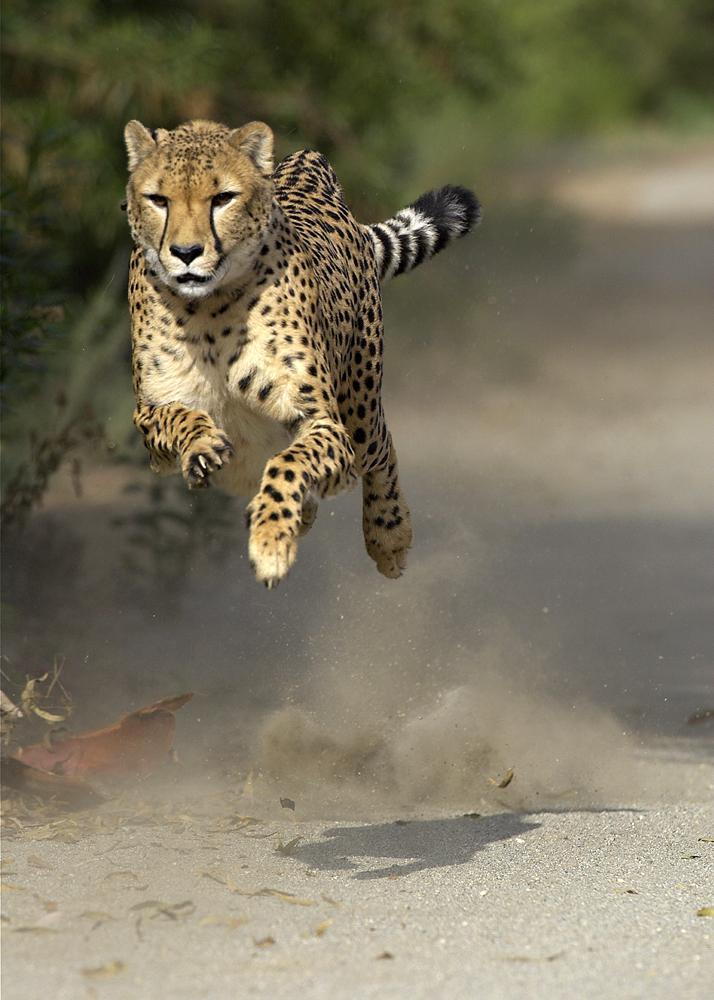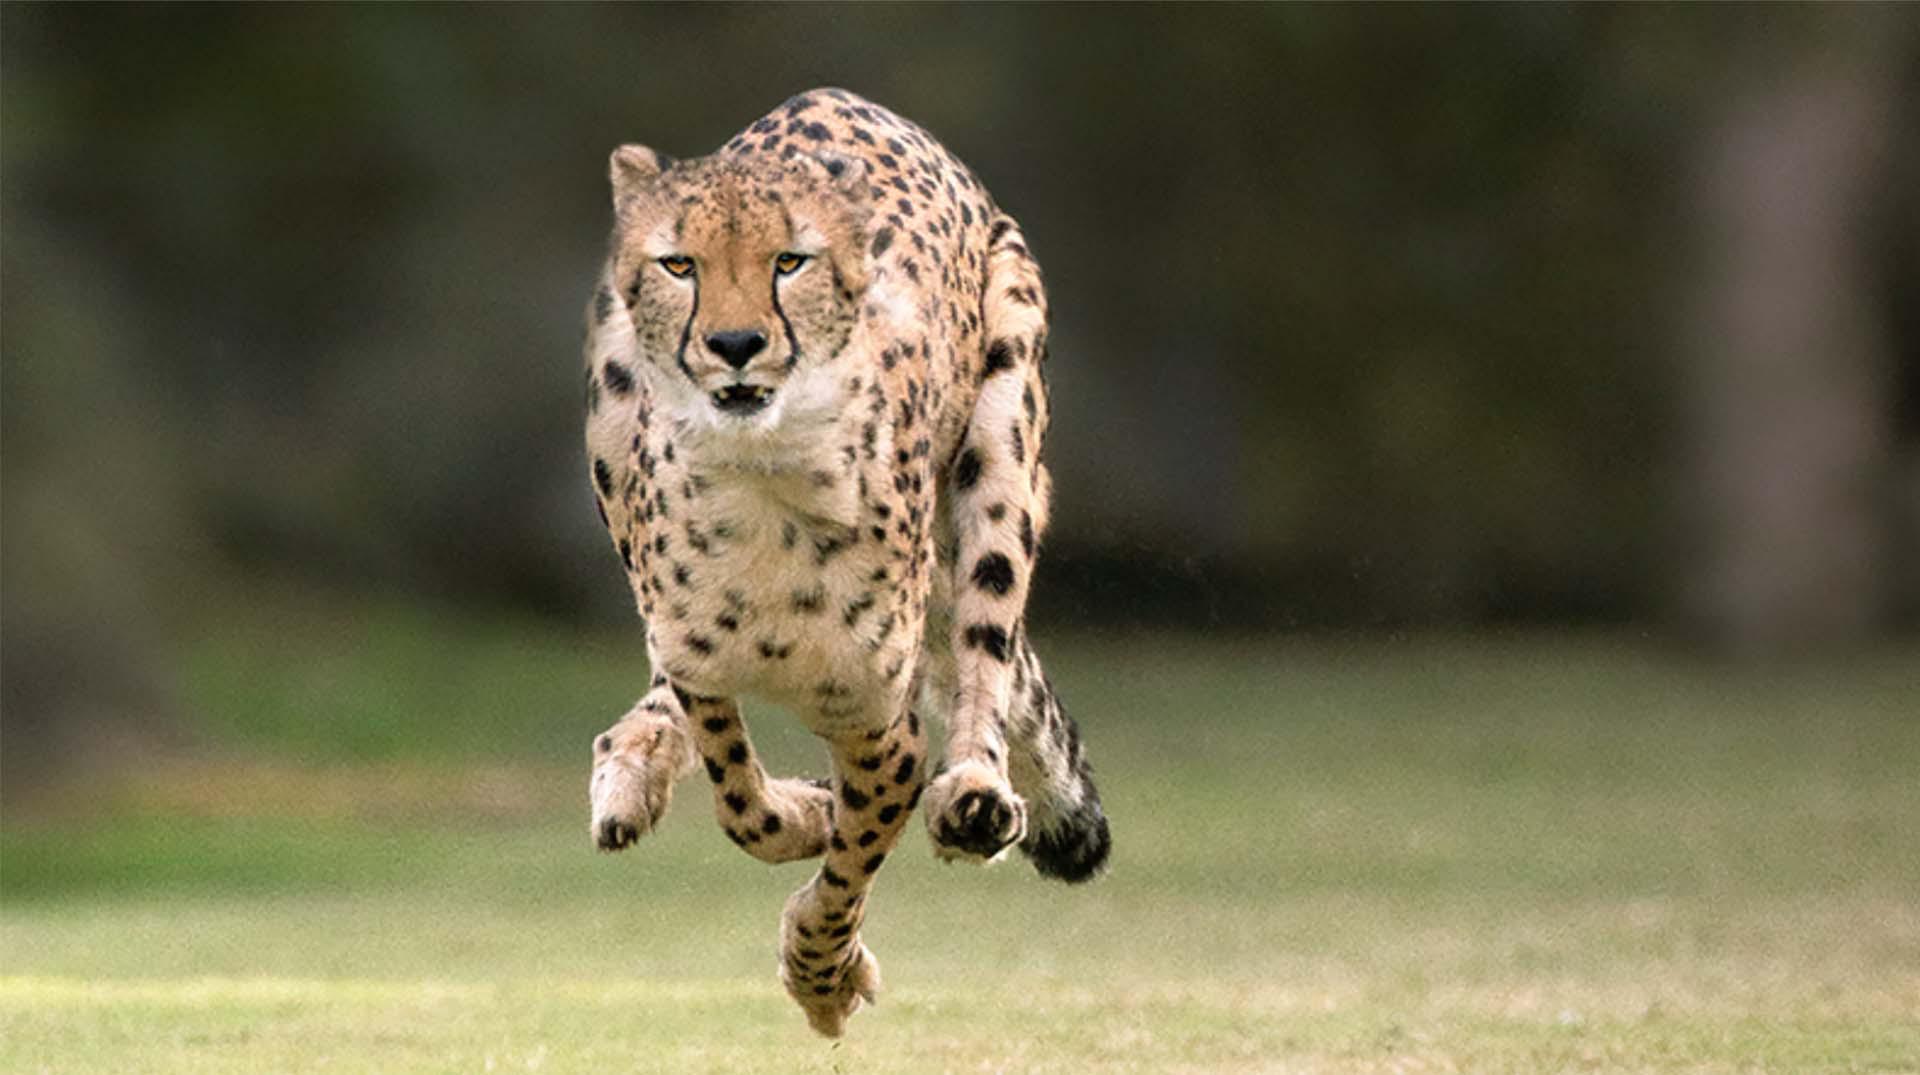The first image is the image on the left, the second image is the image on the right. Evaluate the accuracy of this statement regarding the images: "A cheetah is in bounding pose, with its back legs forward, in front of its front legs.". Is it true? Answer yes or no. Yes. The first image is the image on the left, the second image is the image on the right. Given the left and right images, does the statement "A single leopard is lying down in the image on the left." hold true? Answer yes or no. No. 